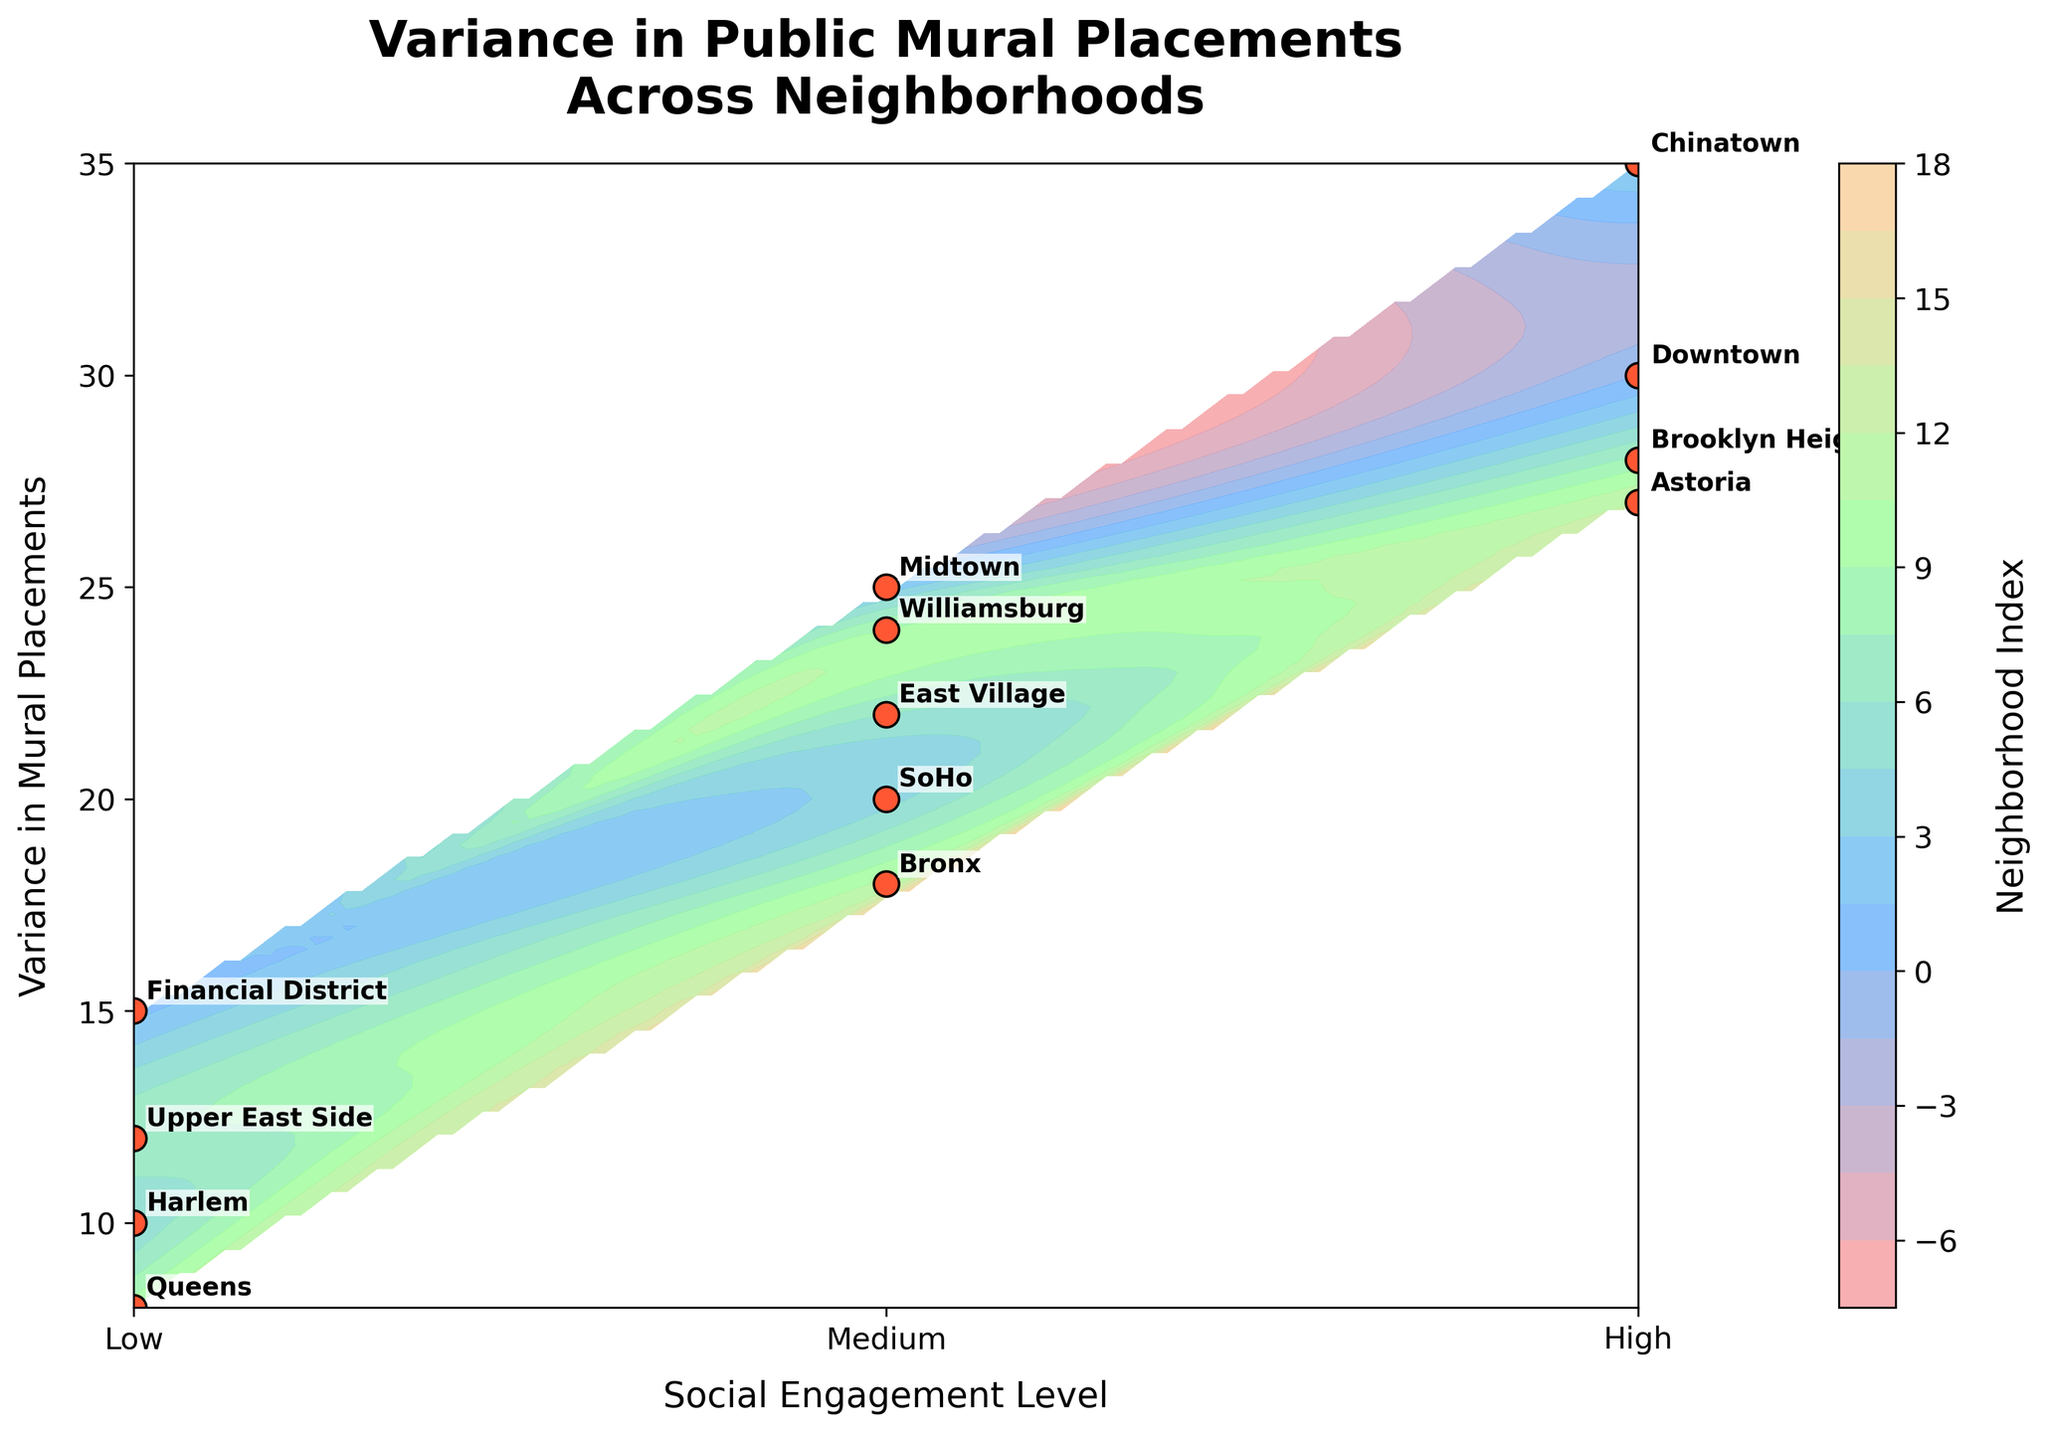What's the title of the plot? The title of the plot is written at the top center of the figure.
Answer: "Variance in Public Mural Placements Across Neighborhoods" How many different levels of social engagement are shown on the x-axis? The x-axis shows three different levels of social engagement, which are labeled as Low, Medium, and High.
Answer: 3 Which neighborhood has the highest variance in mural placements? The highest point on the y-axis corresponds to the highest variance, which is labeled as Chinatown.
Answer: Chinatown What is the social engagement level and variance in mural placements for Harlem? Locate Harlem on the plot and note its position on the x-axis and y-axis. Harlem is found at a low social engagement level and a variance of 10.
Answer: Low, 10 Which neighborhood has a medium social engagement level with a variance in mural placements of 18? Find the point on the plot with a medium social engagement level and a variance of 18, which is labeled as Bronx.
Answer: Bronx What is the variance in mural placements for neighborhoods with high social engagement levels? Identify the neighborhoods labeled at the highest x-axis level (High), and note their variances: Downtown (30), Chinatown (35), Brooklyn Heights (28), Astoria (27).
Answer: 30, 35, 28, 27 How does the variance in mural placements for the Financial District compare to that of SoHo? Compare their y-axis positions: Financial District (15) is lower than SoHo (20).
Answer: Lower What range of variances in mural placements is covered by neighborhoods with low social engagement levels? Identify the y-axis positions of the neighborhoods with low social engagement: Financial District (15), Harlem (10), Upper East Side (12), Queens (8). The range is from 8 to 15.
Answer: 8 to 15 Is there any neighborhood with both high social engagement and a variance in mural placements below 20? Check the high social engagement level area (x-axis) for any points below y=20. No such points exist.
Answer: No Which social engagement level has the most variation in mural placement variances among its neighborhoods? Compare the spread of variances (y-values) for each social engagement level: Low (8, 10, 12, 15), Medium (18, 20, 22, 24), High (27, 28, 30, 35). Medium has the largest range (18 to 24).
Answer: Medium 